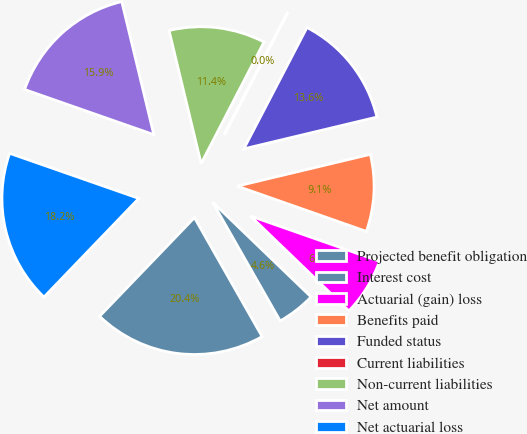Convert chart to OTSL. <chart><loc_0><loc_0><loc_500><loc_500><pie_chart><fcel>Projected benefit obligation<fcel>Interest cost<fcel>Actuarial (gain) loss<fcel>Benefits paid<fcel>Funded status<fcel>Current liabilities<fcel>Non-current liabilities<fcel>Net amount<fcel>Net actuarial loss<nl><fcel>20.42%<fcel>4.57%<fcel>6.83%<fcel>9.1%<fcel>13.63%<fcel>0.04%<fcel>11.36%<fcel>15.89%<fcel>18.16%<nl></chart> 